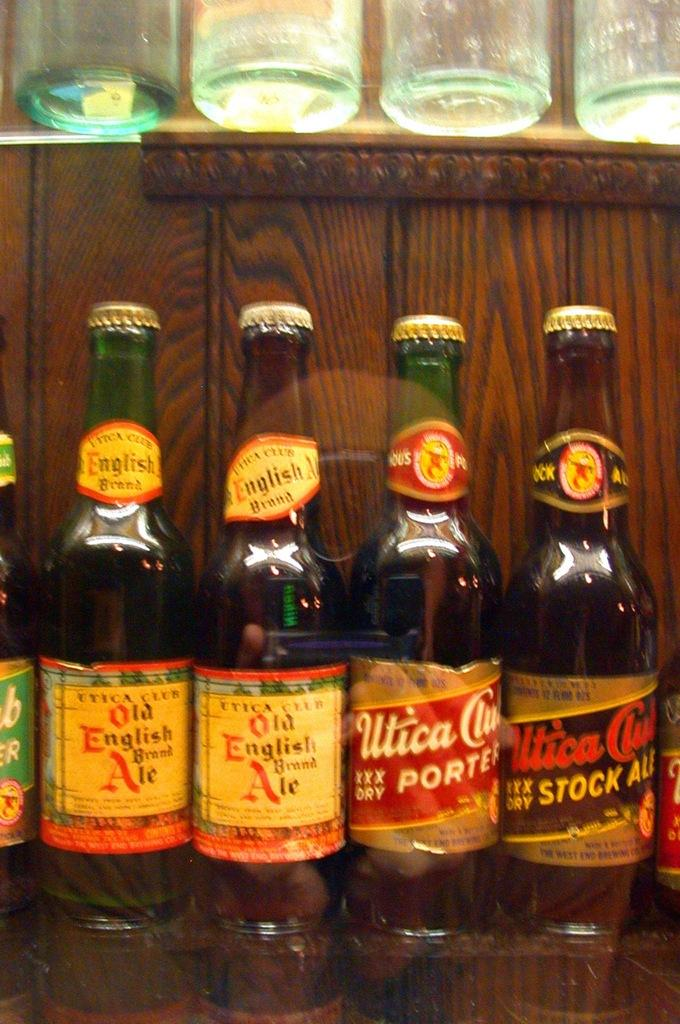<image>
Describe the image concisely. several bottles of beer lined up including Old English Ale 